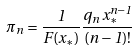Convert formula to latex. <formula><loc_0><loc_0><loc_500><loc_500>\pi _ { n } = \frac { 1 } { F ( x _ { * } ) } \frac { q _ { n } \, x _ { * } ^ { n - 1 } } { ( n - 1 ) ! }</formula> 